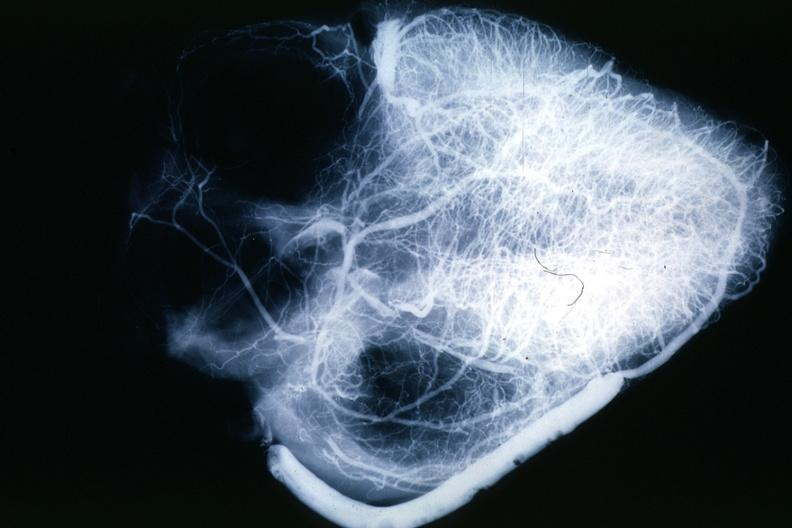s chronic ischemia present?
Answer the question using a single word or phrase. No 